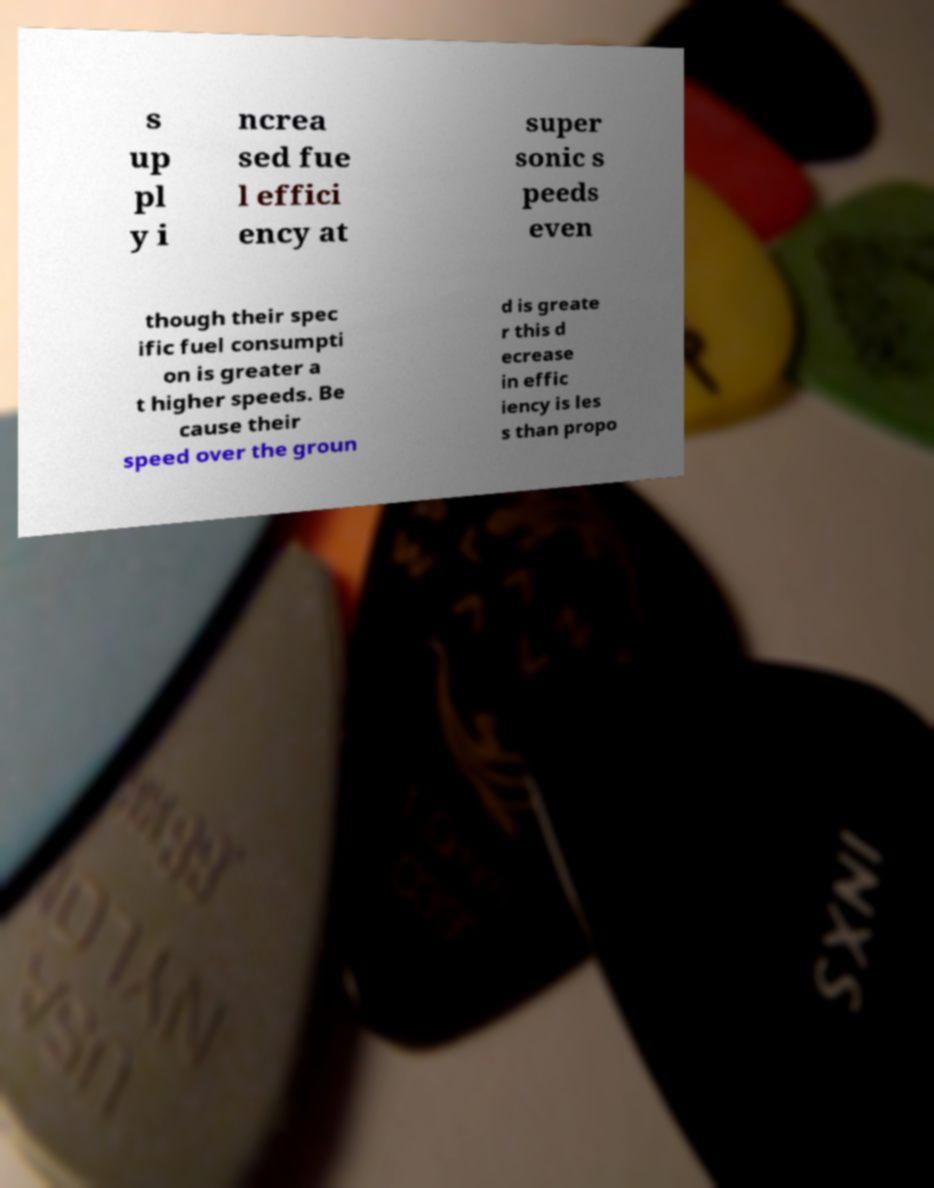There's text embedded in this image that I need extracted. Can you transcribe it verbatim? s up pl y i ncrea sed fue l effici ency at super sonic s peeds even though their spec ific fuel consumpti on is greater a t higher speeds. Be cause their speed over the groun d is greate r this d ecrease in effic iency is les s than propo 